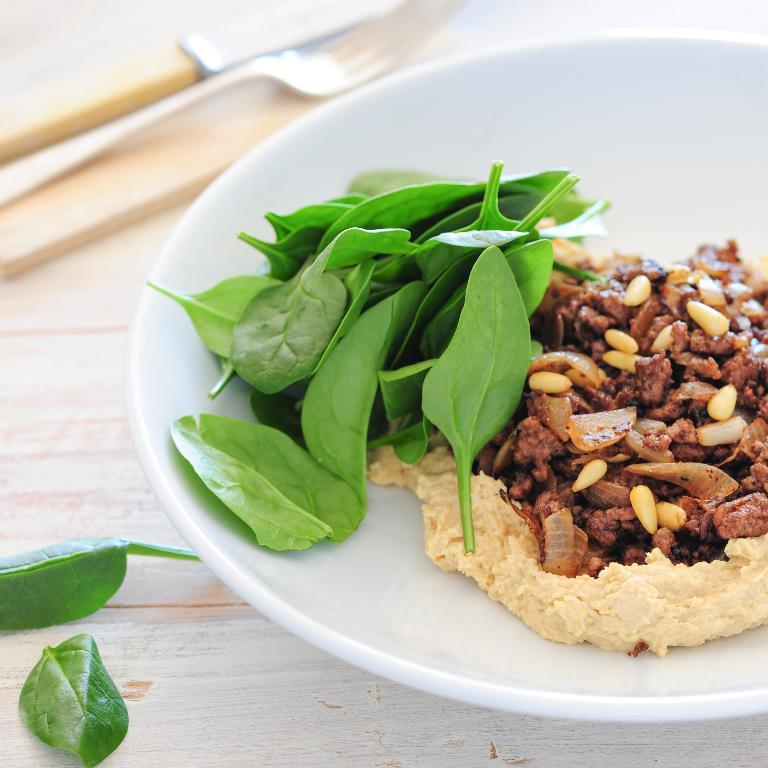What is on the plate in the image? There is food and leafy vegetables on the plate in the image. Where is the plate located? The plate is placed on a table. What utensils are visible in the image? There is a knife and a fork in the image. What else can be seen in the image besides the plate and utensils? There are leaves present in the image. What type of apparel is the insect wearing in the image? There is no insect present in the image, and therefore no apparel can be observed. 